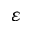Convert formula to latex. <formula><loc_0><loc_0><loc_500><loc_500>\varepsilon</formula> 